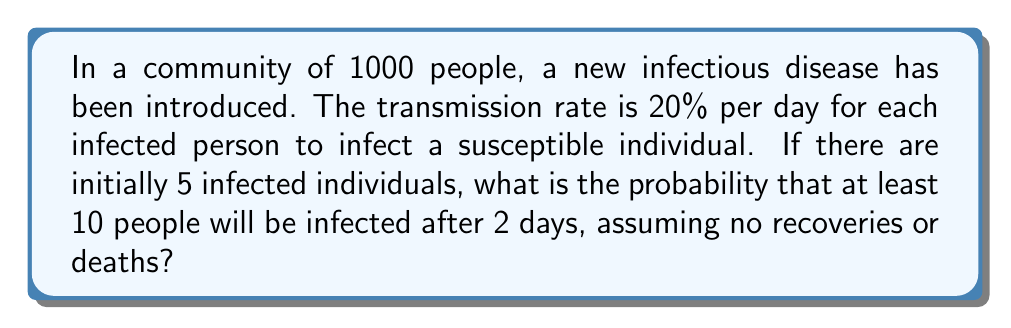Solve this math problem. Let's approach this step-by-step:

1) First, we need to calculate the probability of a single infected person infecting a susceptible person over 2 days:
   
   $P(\text{infection in 2 days}) = 1 - (1 - 0.2)^2 = 1 - 0.64 = 0.36$

2) Now, for each of the 5 initially infected individuals, we can model the number of new infections as a binomial distribution with $n = 995$ (the number of susceptible individuals) and $p = 0.36$:

   $X_i \sim \text{Binomial}(995, 0.36)$ for $i = 1, 2, 3, 4, 5$

3) The total number of new infections is the sum of these 5 binomial distributions:

   $Y = X_1 + X_2 + X_3 + X_4 + X_5$

4) This sum follows a binomial distribution with parameters:

   $Y \sim \text{Binomial}(5 \times 995, 0.36)$

5) We want to find $P(Y \geq 5)$, as this would result in at least 10 total infections (5 initial + at least 5 new).

6) Using the normal approximation to the binomial distribution (which is valid here due to the large n):

   $\mu = np = 5 \times 995 \times 0.36 = 1791$
   $\sigma = \sqrt{np(1-p)} = \sqrt{1791 \times 0.64} = 33.82$

7) Standardizing:

   $z = \frac{5 - 1791}{33.82} = -52.81$

8) The probability $P(Y \geq 5)$ is equivalent to $P(Z \geq -52.81)$, which is essentially 1.

Therefore, the probability of at least 10 people being infected after 2 days is virtually certain (> 0.9999).
Answer: $\approx 1$ 